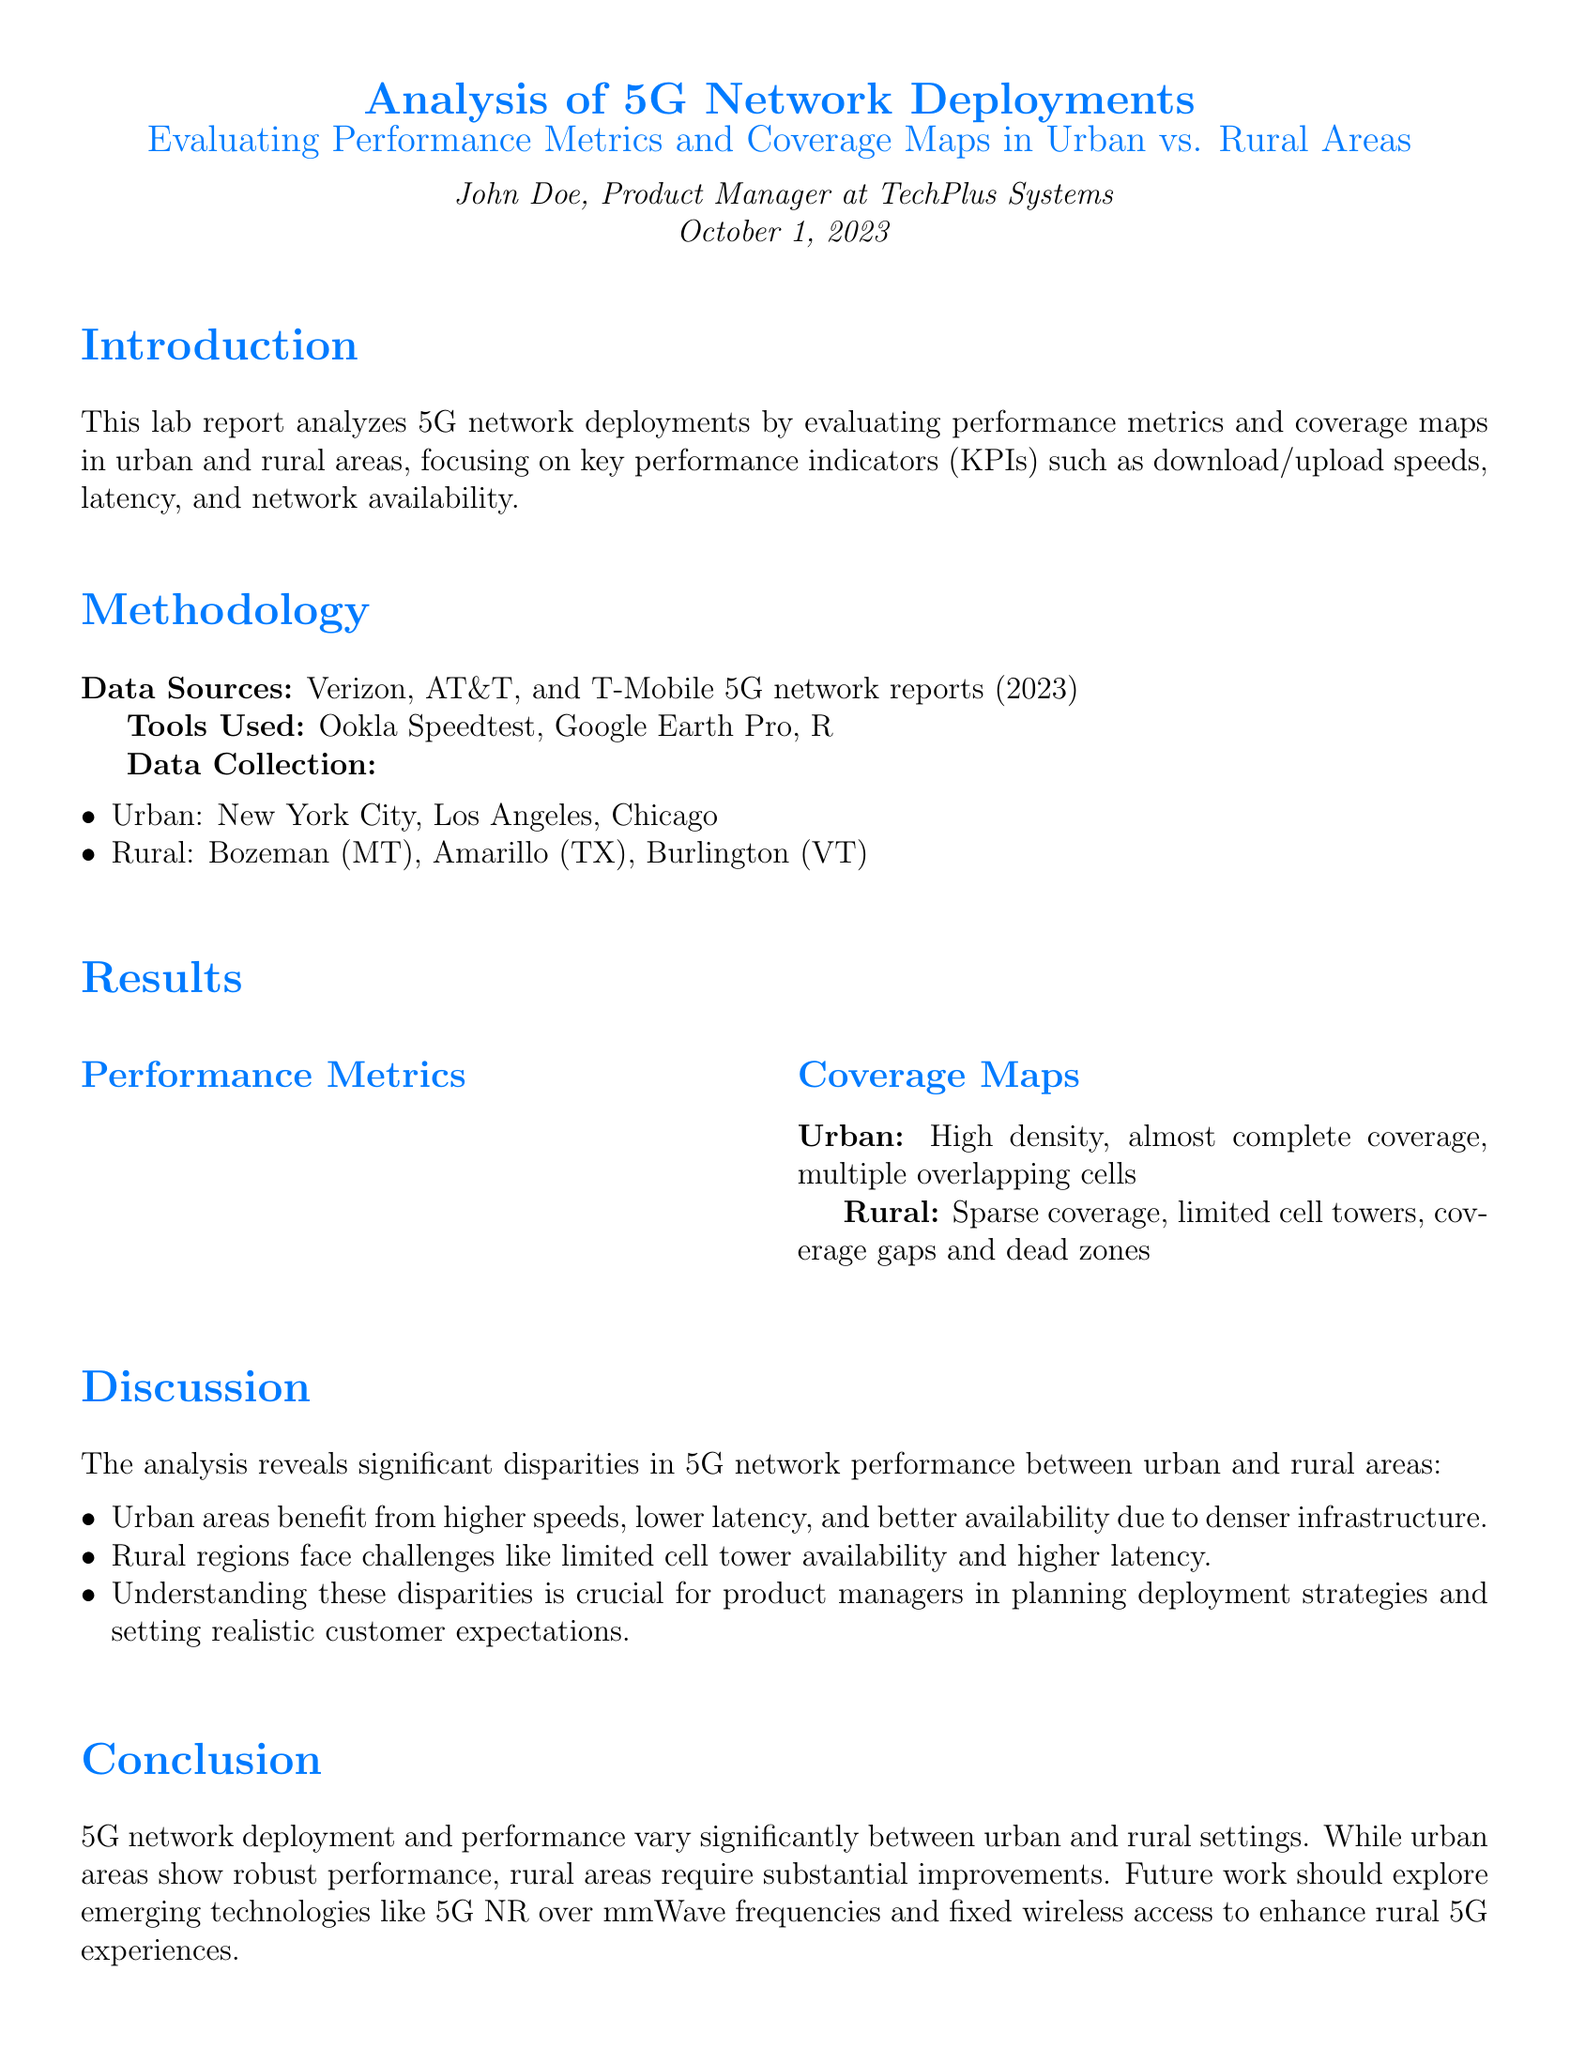What is the average download speed in urban areas? The average download speed is provided in the performance metrics table for urban areas.
Answer: 450 Mbps What is the average upload speed in rural areas? The average upload speed can be found in the performance metrics table for rural areas.
Answer: 20 Mbps What is the average latency in urban areas? The average latency metric for urban areas is listed in the results section of the document.
Answer: 20 ms What percentage of network availability is reported for rural areas? The percentage of network availability for rural areas is specified in the performance metrics table.
Answer: 85% Which areas were included in the urban data collection? The document lists specific cities that represent urban areas for data collection.
Answer: New York City, Los Angeles, Chicago What is a key challenge faced by rural regions according to the discussion? The challenges faced by rural regions are discussed and summarized in a bullet point.
Answer: Limited cell tower availability How do urban areas compare to rural areas in terms of network availability? The analysis points out the differences between urban and rural network availability, emphasizing the urban advantage.
Answer: Better availability What is suggested for future work in enhancing rural 5G experiences? The conclusion outlines proposed areas for future development regarding rural 5G enhancements.
Answer: Emerging technologies like 5G NR over mmWave frequencies What are the main tools used in this analysis? The methodology section lists the tools that were utilized for the analysis of 5G deployments.
Answer: Ookla Speedtest, Google Earth Pro, R 